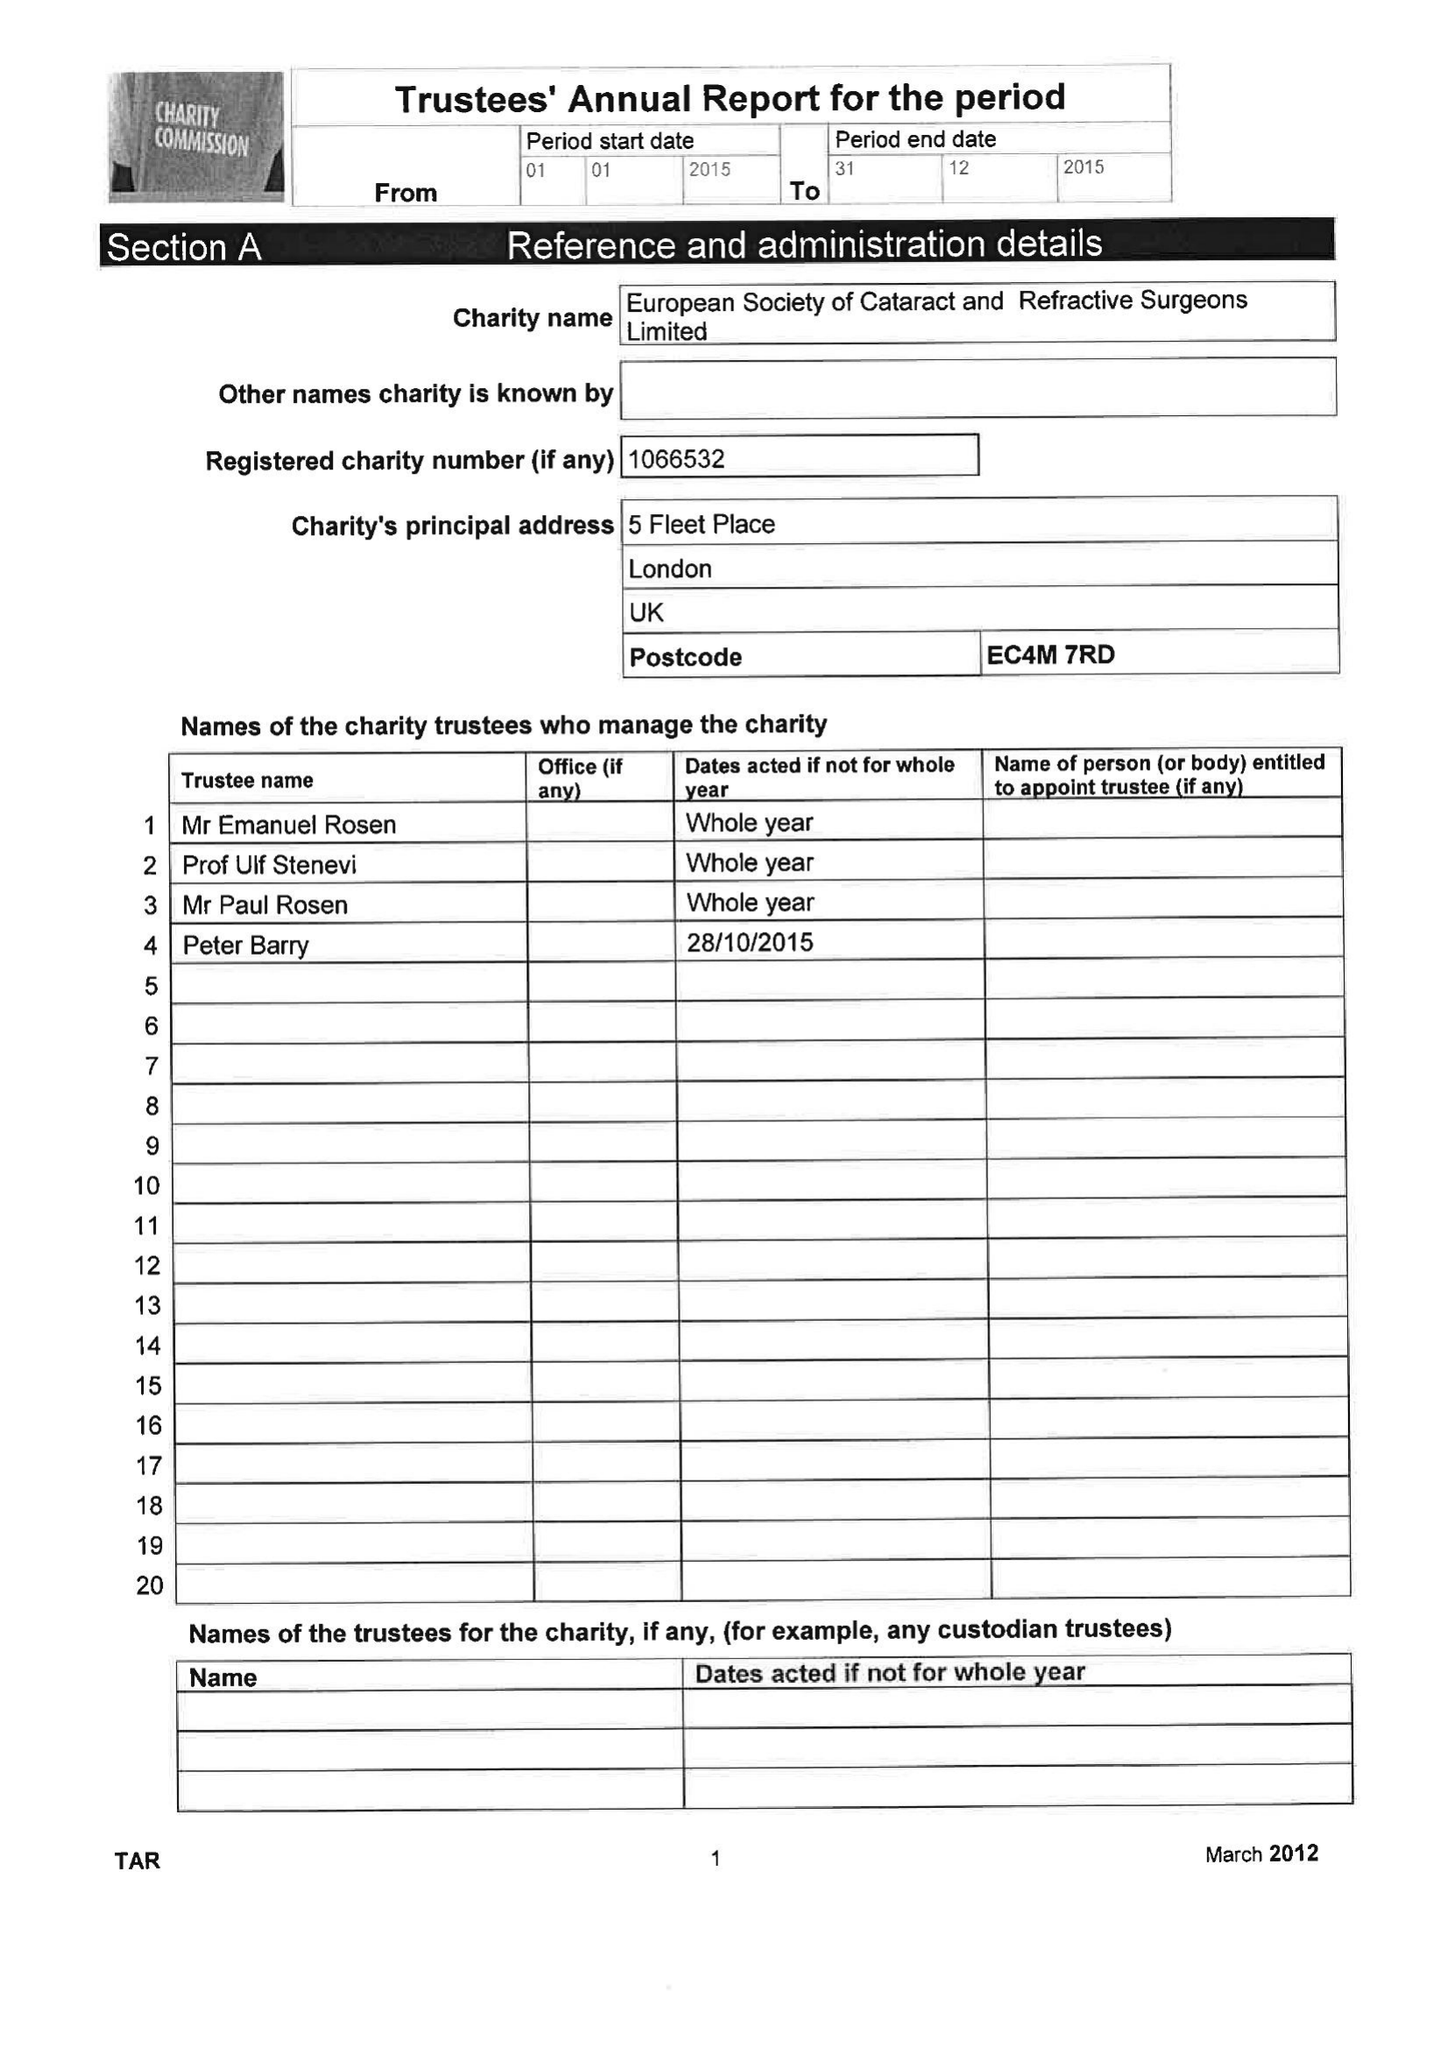What is the value for the address__postcode?
Answer the question using a single word or phrase. EC4M 7RD 